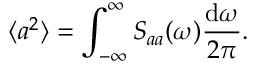Convert formula to latex. <formula><loc_0><loc_0><loc_500><loc_500>\langle a ^ { 2 } \rangle = \int _ { - \infty } ^ { \infty } S _ { a a } ( \omega ) \frac { d \omega } { 2 \pi } .</formula> 